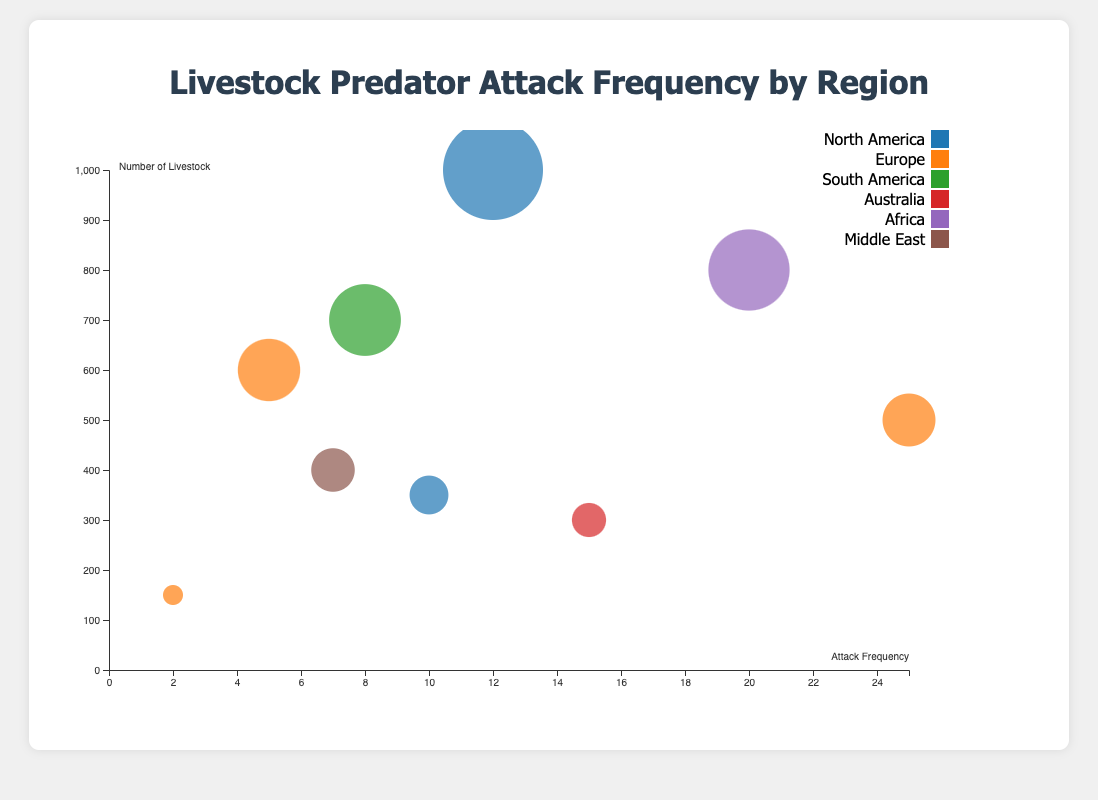What is the title of the chart? The title of the chart is usually displayed prominently at the top of the chart. In this case, it is "Livestock Predator Attack Frequency by Region".
Answer: Livestock Predator Attack Frequency by Region How many breeds of livestock are shown in the chart? Count the different breeds listed in the data points of the chart. There are nine distinct breeds displayed.
Answer: Nine Which breed and region combination has the highest attack frequency? Look for the data point with the highest value on the x-axis, which represents attack frequency. The Merino Sheep in Europe, with an attack frequency of 25, has the highest value.
Answer: Merino Sheep in Europe What are the axes labels of the chart? The axes labels are typically found near the axes. The x-axis is labeled "Attack Frequency" and the y-axis is labeled "Number of Livestock".
Answer: Attack Frequency and Number of Livestock Which region has the most diverse range of predators shown in the chart? Check the color legend and match it with the different predators. Europe shows the most diverse range of predators: Foxes, Bears, and Eagles.
Answer: Europe Which breed in North America has the larger attack frequency, and what is it? Compare the attack frequencies of breeds in North America. Angus Cattle has an attack frequency of 12, which is larger than Lacaune Sheep's 10.
Answer: Angus Cattle with 12 What is the total livestock count for breeds in Europe? Sum the "NumberOfLivestock" for all breeds in Europe: Merino Sheep (500), Tarentaise Cattle (600), and Highland Cattle (150). The total is 500 + 600 + 150 = 1250.
Answer: 1250 Which region has the highest number of livestock for a single breed, and what is that breed? Check the y-axis values, looking for the highest single point. North America (Angus Cattle) has the highest number with 1000 livestock.
Answer: North America with Angus Cattle What is the average attack frequency of breeds in Europe? Add up the attack frequencies of breeds in Europe and divide by the number of breeds: (25 + 5 + 2) / 3 equals 10.67.
Answer: 10.67 Which breed has the smallest number of livestock, and in which region is it located? Look for the smallest value on the y-axis. The smallest number is for Highland Cattle in Europe with 150 livestock.
Answer: Highland Cattle in Europe 